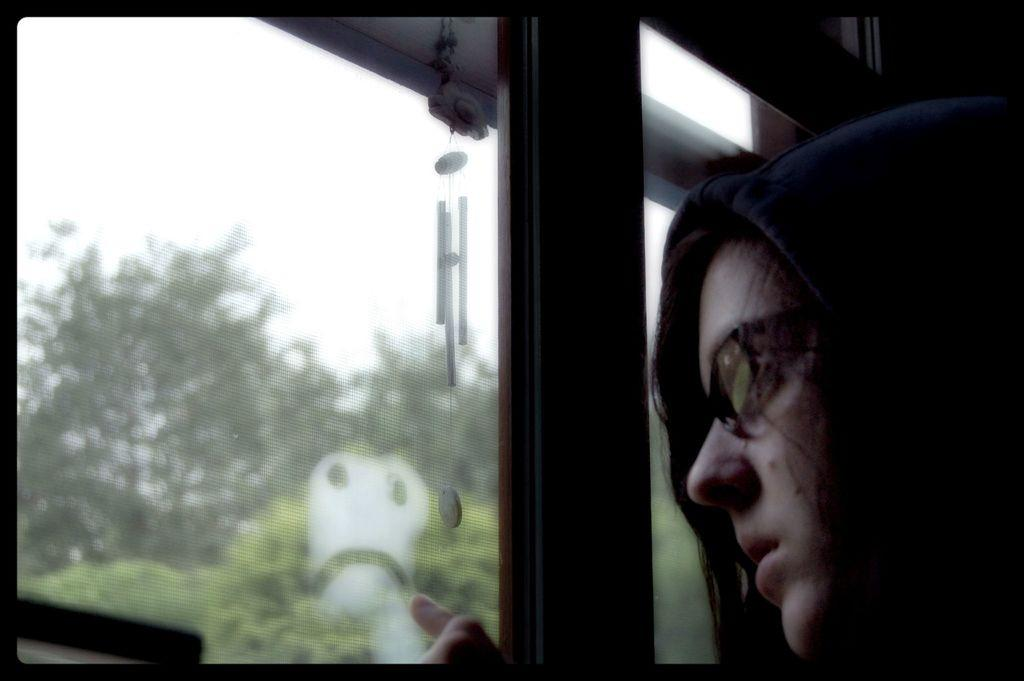Who is present in the image? There is a person in the image. What can be observed about the person's appearance? The person is wearing spectacles. What is the person standing in front of? The person is in front of a glass. What can be seen on the other side of the glass? There are trees and plants on the other side of the glass. What type of comb is the person using to brush their pets in the image? There is no comb or pets present in the image. What is the person celebrating in the image? There is no indication of a celebration or birthday in the image. 